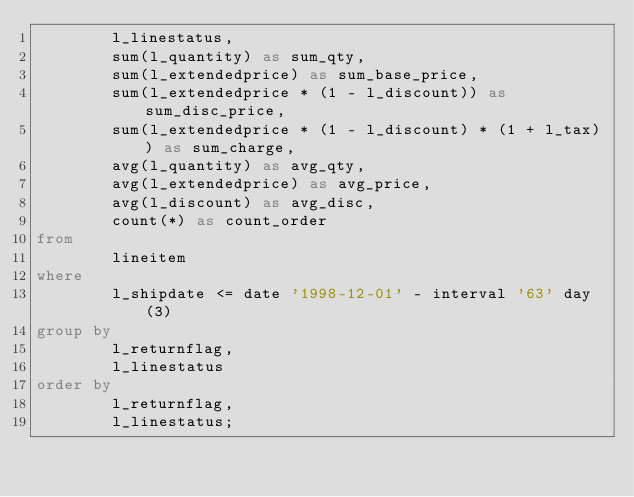Convert code to text. <code><loc_0><loc_0><loc_500><loc_500><_SQL_>        l_linestatus,
        sum(l_quantity) as sum_qty,
        sum(l_extendedprice) as sum_base_price,
        sum(l_extendedprice * (1 - l_discount)) as sum_disc_price,
        sum(l_extendedprice * (1 - l_discount) * (1 + l_tax)) as sum_charge,
        avg(l_quantity) as avg_qty,
        avg(l_extendedprice) as avg_price,
        avg(l_discount) as avg_disc,
        count(*) as count_order
from
        lineitem
where
        l_shipdate <= date '1998-12-01' - interval '63' day (3)
group by
        l_returnflag,
        l_linestatus
order by
        l_returnflag,
        l_linestatus;
</code> 